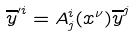<formula> <loc_0><loc_0><loc_500><loc_500>\overline { y } ^ { \prime i } = A _ { j } ^ { i } ( x ^ { \nu } ) \overline { y } ^ { j }</formula> 